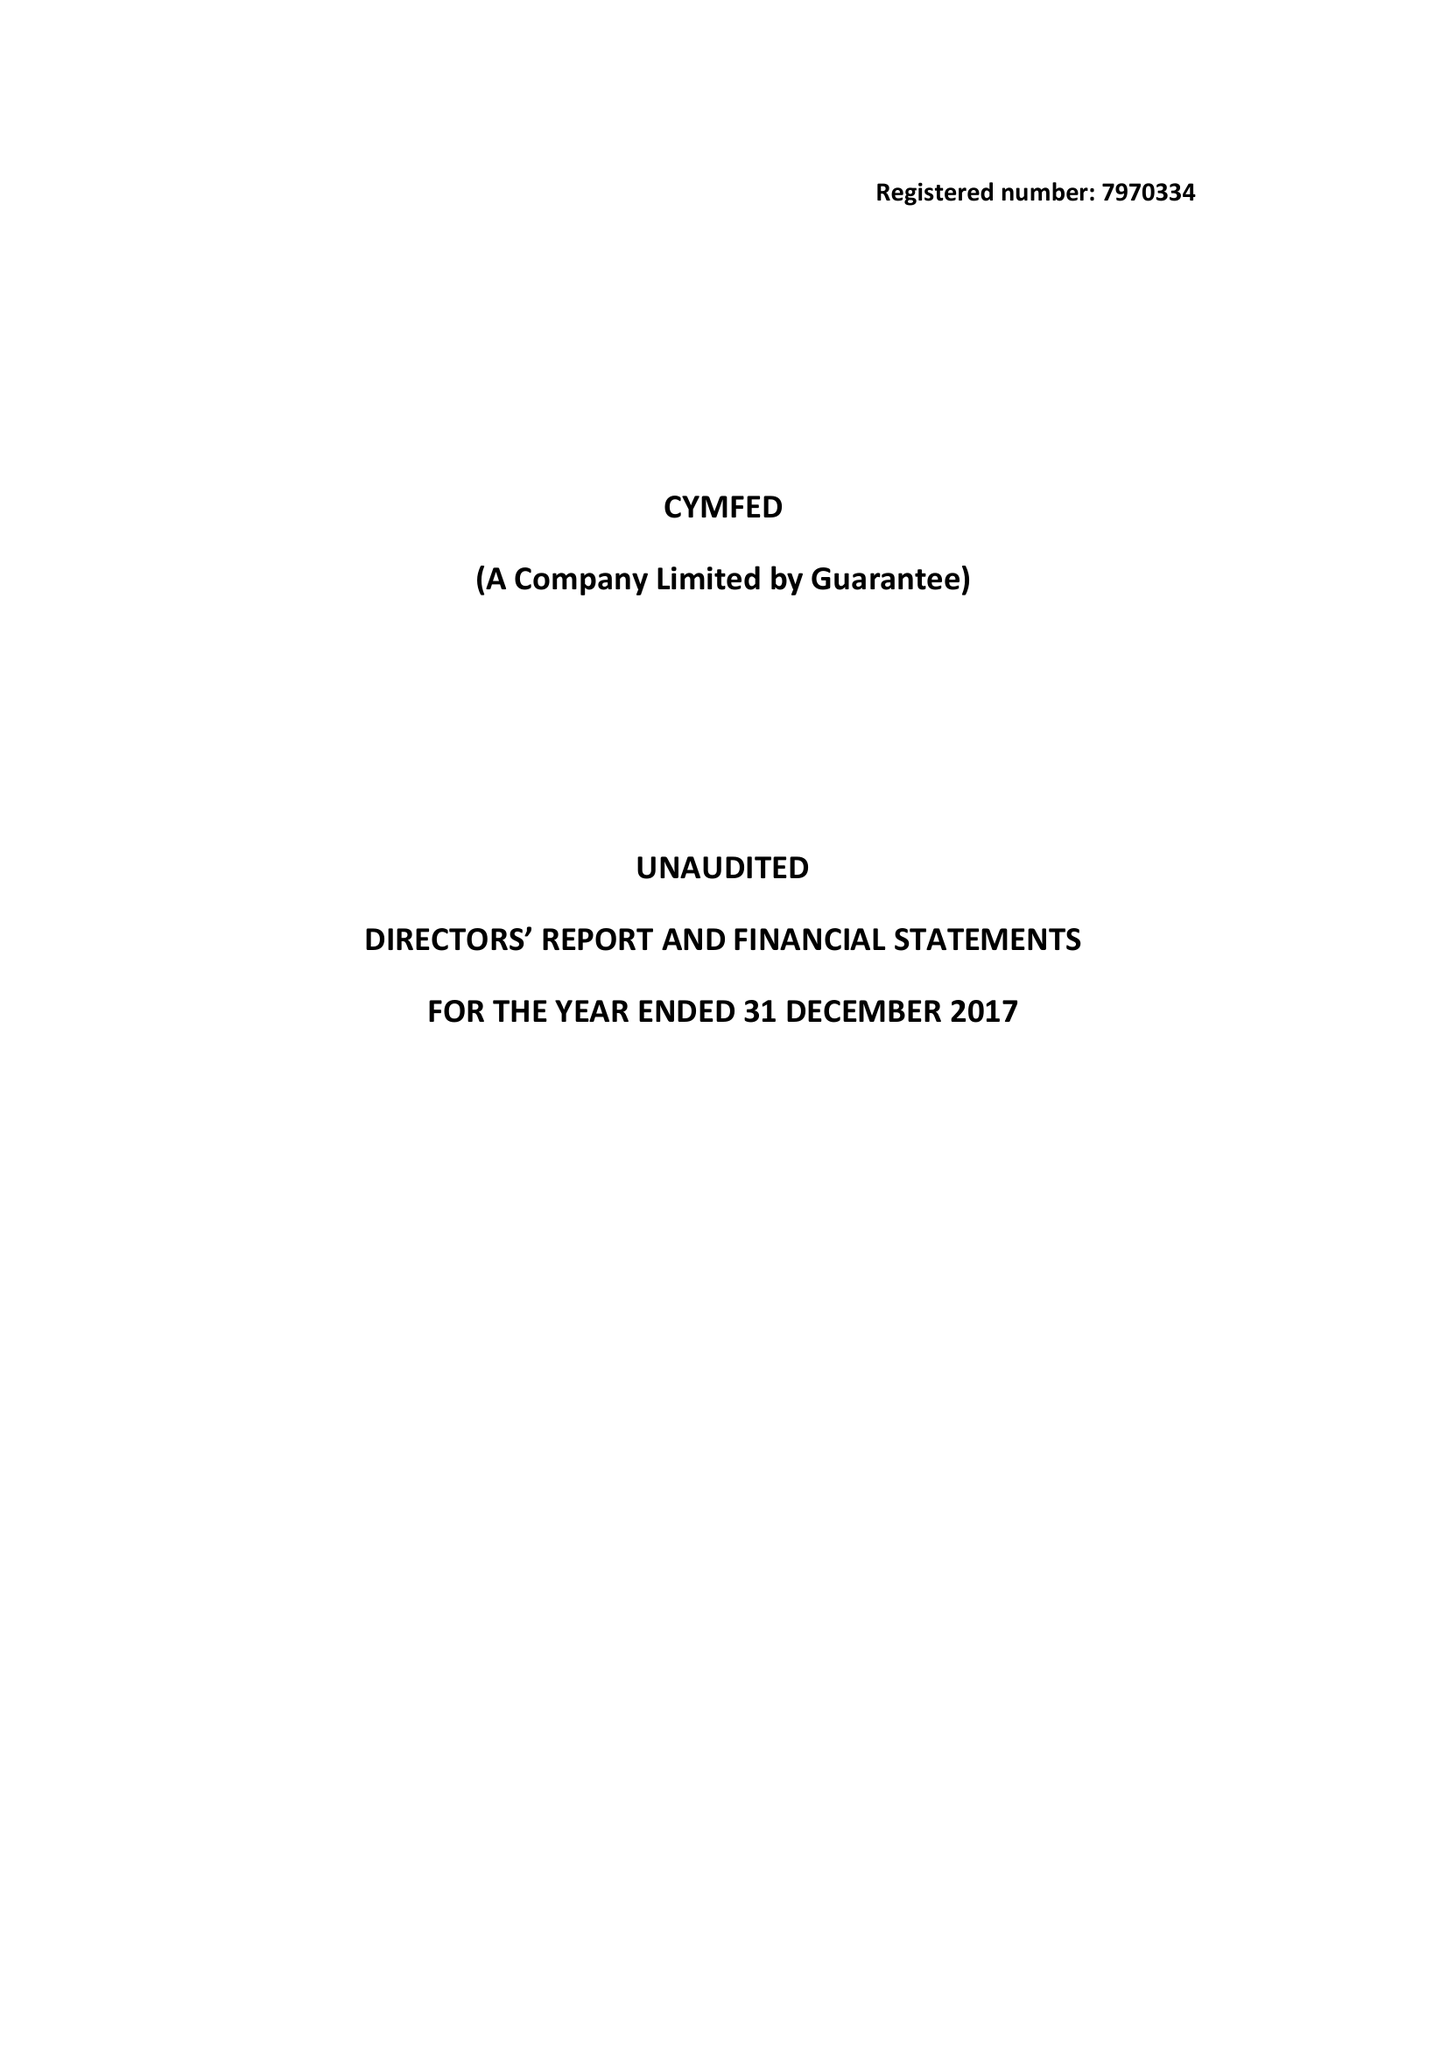What is the value for the address__street_line?
Answer the question using a single word or phrase. 39 ECCLESTON SQUARE 